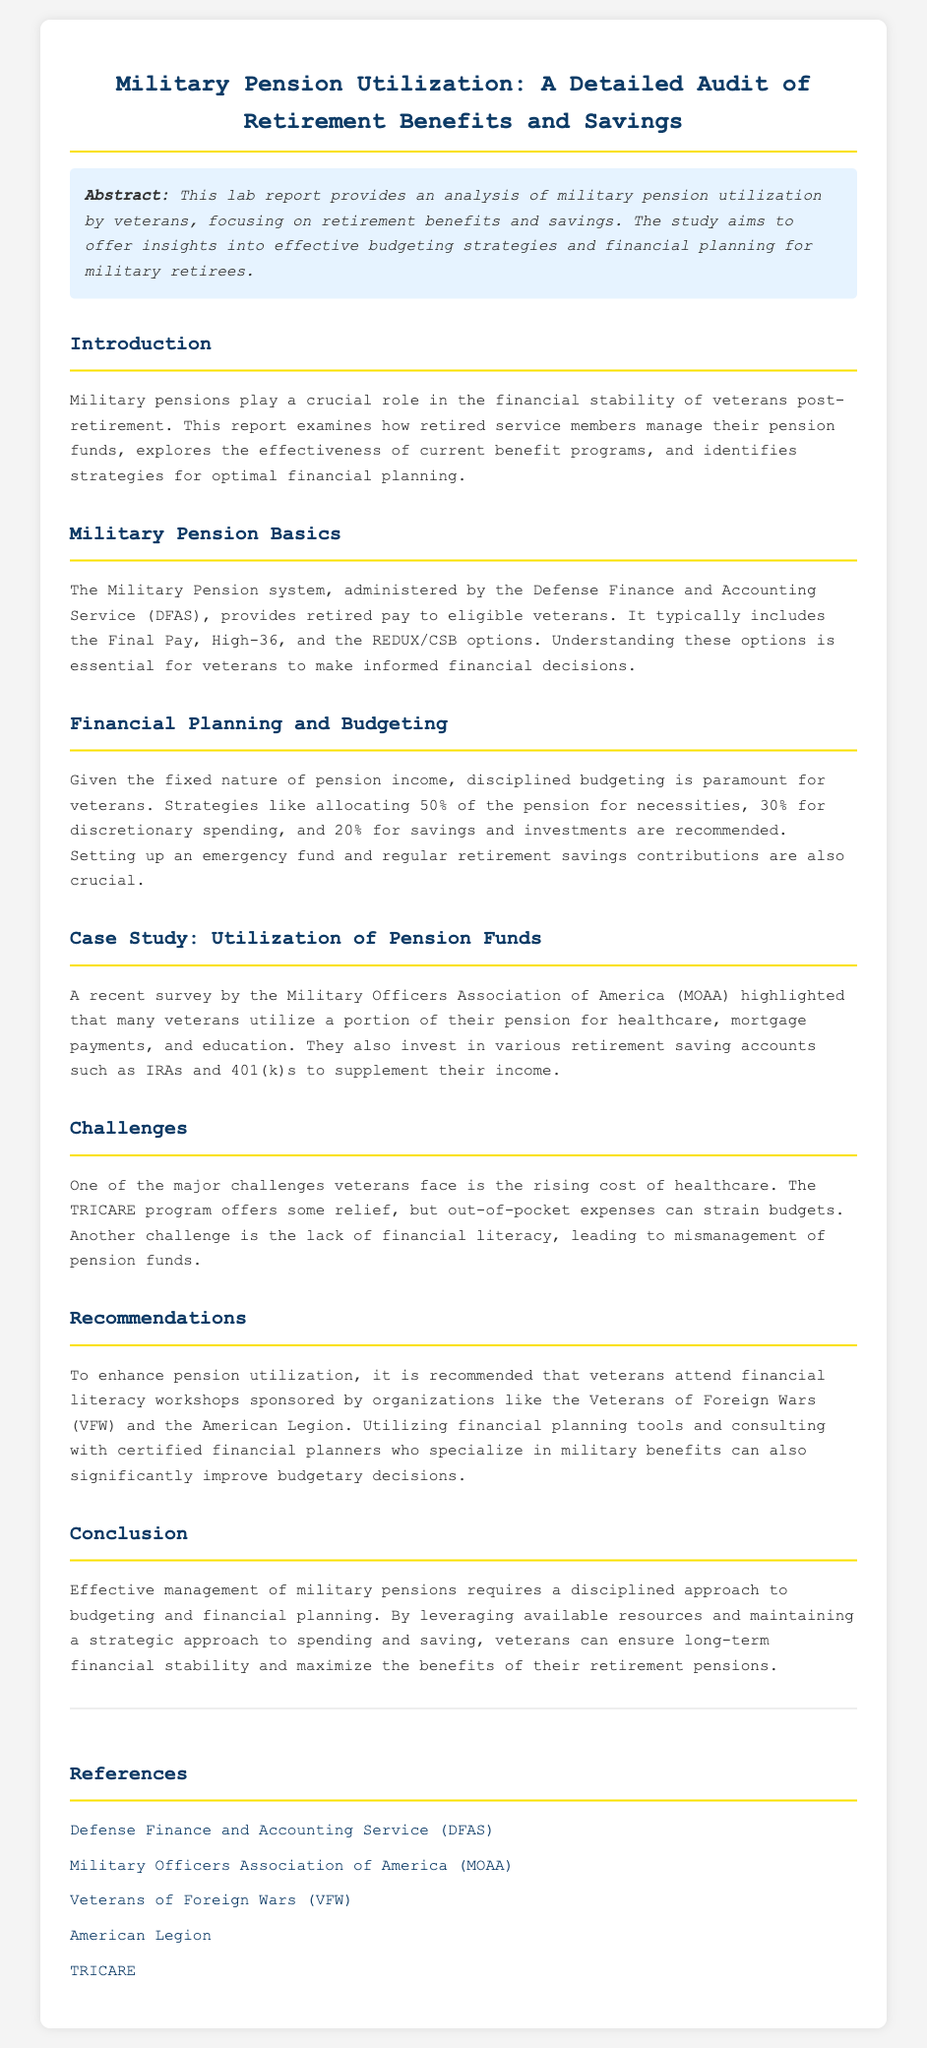What is the title of the report? The title of the report is mentioned at the top of the document.
Answer: Military Pension Utilization: A Detailed Audit of Retirement Benefits and Savings What is the primary focus of the abstract? The abstract summarizes the aim and subject of the report, specifically relating to veterans and financial planning.
Answer: Analysis of military pension utilization What are the three pension options mentioned? The document lists the pension options available to veterans, essential for informed financial decisions.
Answer: Final Pay, High-36, REDUX/CSB What percentage of the pension is recommended for savings and investments? The document outlines a suggested allocation for effective budgeting based on the fixed nature of pension income.
Answer: 20% What organization conducted a survey on pension fund utilization? This question pertains to the source of the case study highlighted in the report.
Answer: Military Officers Association of America (MOAA) What is one major challenge faced by veterans regarding healthcare costs? The report discusses the financial pressures veterans face in relation to healthcare expenses.
Answer: Rising cost of healthcare Which program offers some relief for healthcare expenses? This question relates to the assistance available to veterans for managing healthcare costs mentioned in the report.
Answer: TRICARE What is recommended for veterans to improve financial literacy? The report suggests a specific type of program to help veterans with their financial understanding.
Answer: Attend financial literacy workshops What is the overall conclusion of the report? The conclusion encapsulates the main findings and advice regarding pension management for veterans.
Answer: Effective management of military pensions requires a disciplined approach to budgeting 